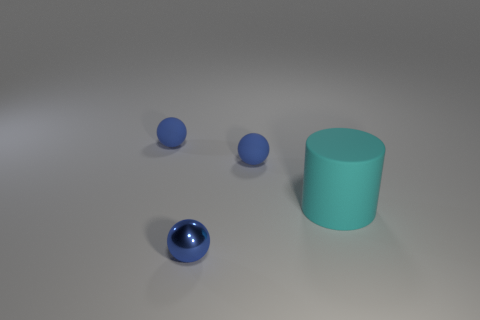What might be the purpose of creating this image, or what concepts could it visually represent? This image may serve various conceptual purposes. It could represent themes of uniqueness and uniformity through the varied textures and consistent color of the spheres. It might be used to illustrate physical concepts like light and reflection, as seen in how the surfaces interact with the light source. Or it could simply be a 3D rendering exercise, focusing on the creation of realistic materials and shadows in a virtual environment. 